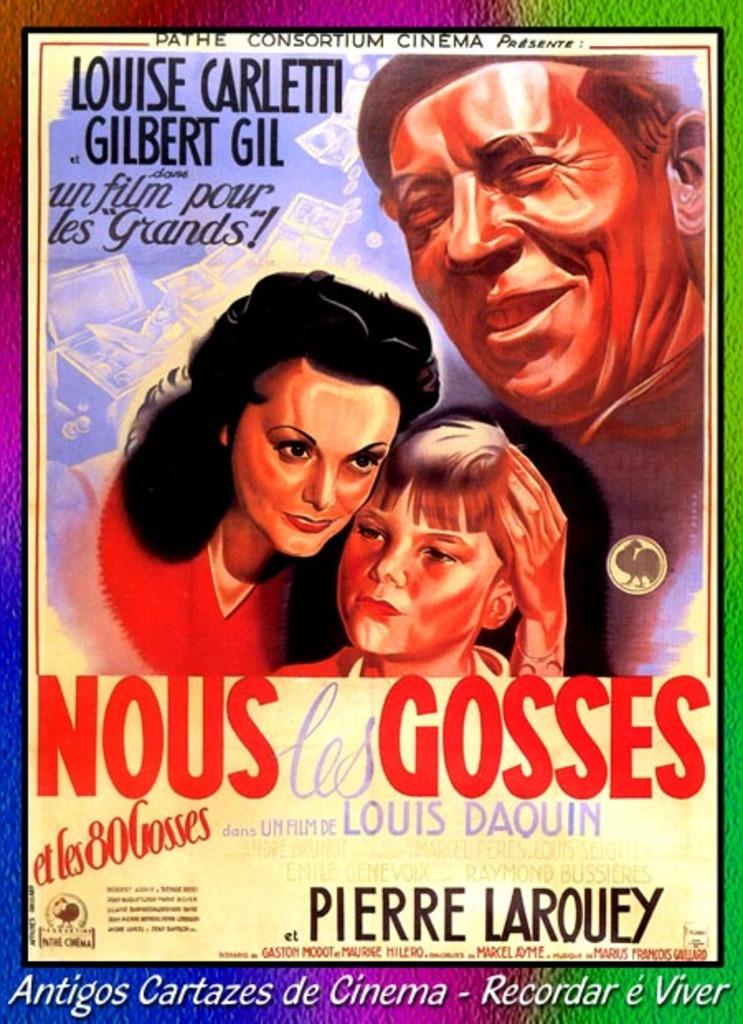<image>
Share a concise interpretation of the image provided. The cinema poster shown is called Nous les Gosses. 